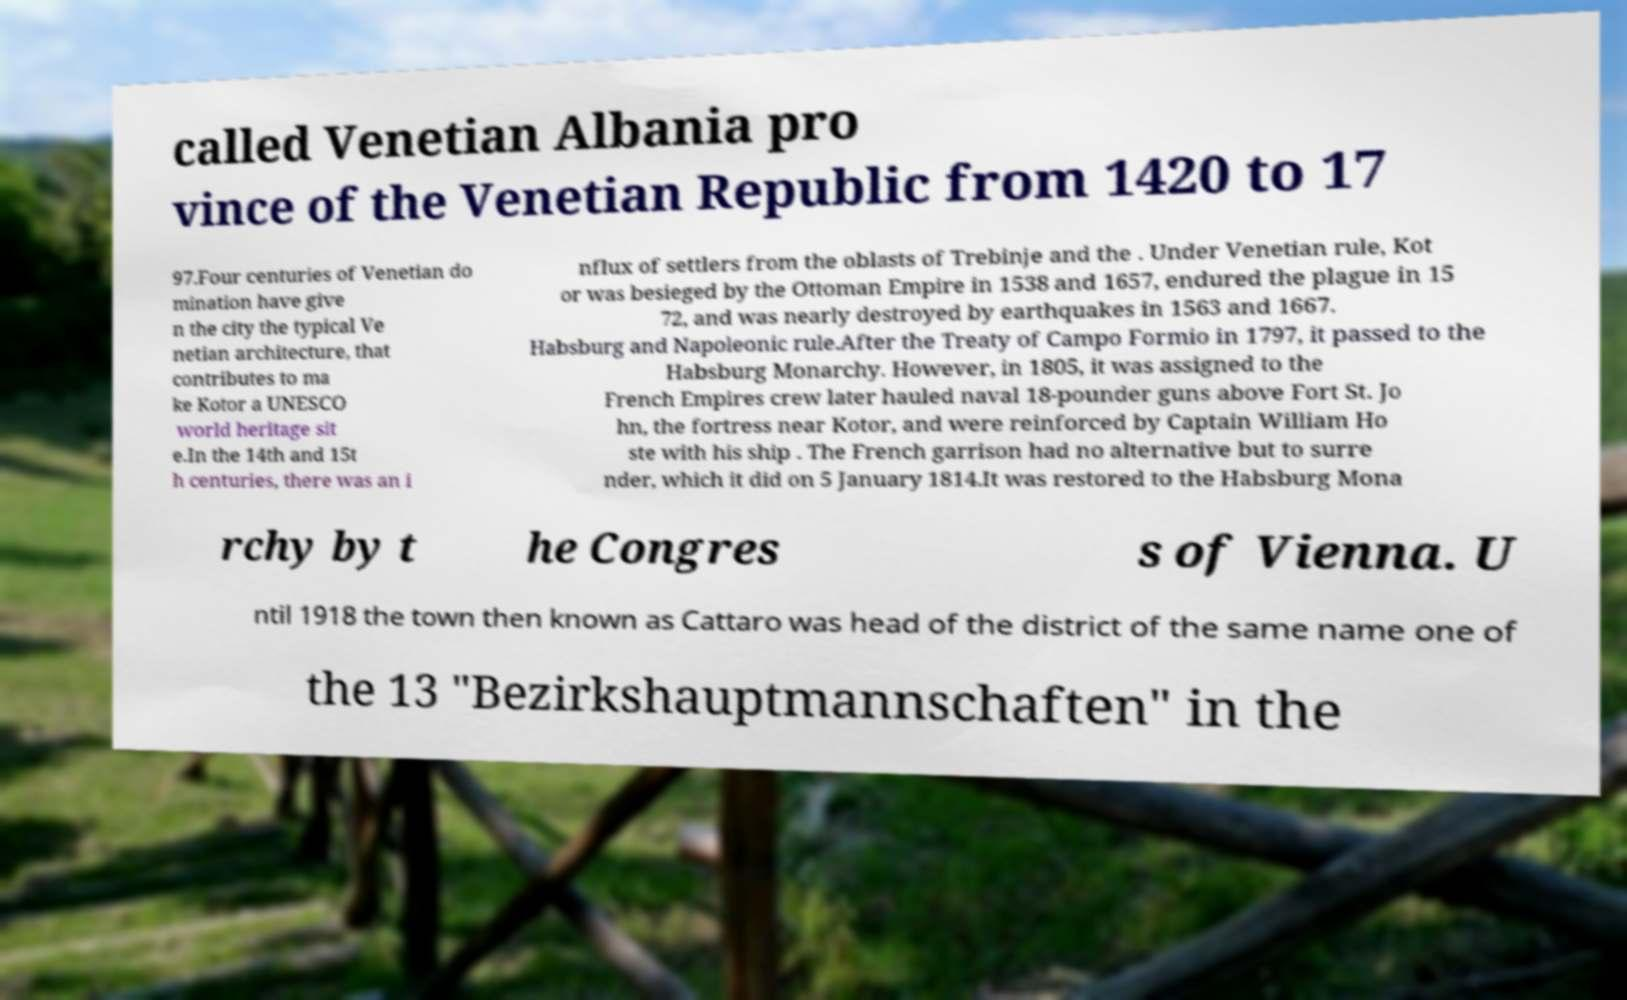Could you assist in decoding the text presented in this image and type it out clearly? called Venetian Albania pro vince of the Venetian Republic from 1420 to 17 97.Four centuries of Venetian do mination have give n the city the typical Ve netian architecture, that contributes to ma ke Kotor a UNESCO world heritage sit e.In the 14th and 15t h centuries, there was an i nflux of settlers from the oblasts of Trebinje and the . Under Venetian rule, Kot or was besieged by the Ottoman Empire in 1538 and 1657, endured the plague in 15 72, and was nearly destroyed by earthquakes in 1563 and 1667. Habsburg and Napoleonic rule.After the Treaty of Campo Formio in 1797, it passed to the Habsburg Monarchy. However, in 1805, it was assigned to the French Empires crew later hauled naval 18-pounder guns above Fort St. Jo hn, the fortress near Kotor, and were reinforced by Captain William Ho ste with his ship . The French garrison had no alternative but to surre nder, which it did on 5 January 1814.It was restored to the Habsburg Mona rchy by t he Congres s of Vienna. U ntil 1918 the town then known as Cattaro was head of the district of the same name one of the 13 "Bezirkshauptmannschaften" in the 